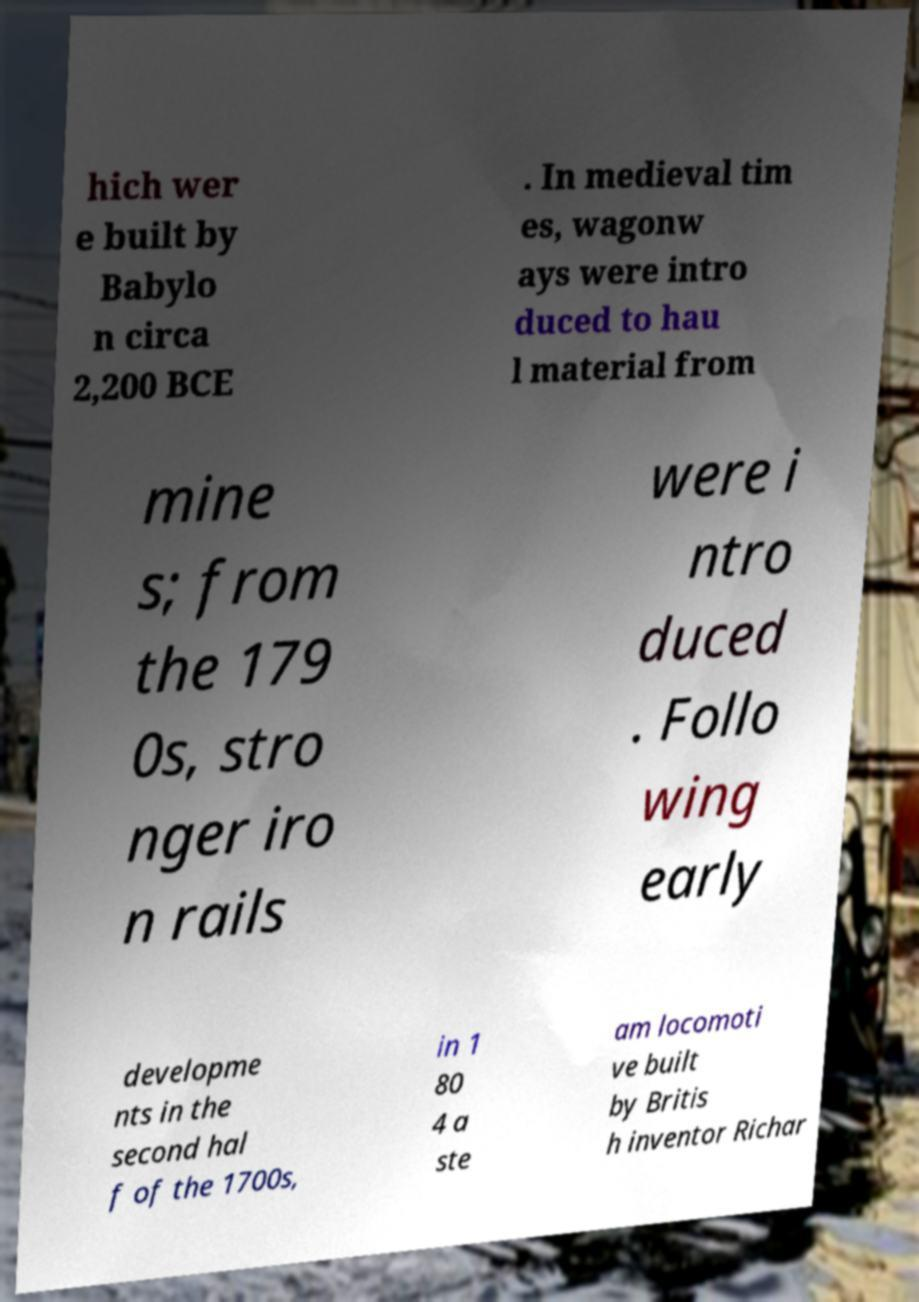Please identify and transcribe the text found in this image. hich wer e built by Babylo n circa 2,200 BCE . In medieval tim es, wagonw ays were intro duced to hau l material from mine s; from the 179 0s, stro nger iro n rails were i ntro duced . Follo wing early developme nts in the second hal f of the 1700s, in 1 80 4 a ste am locomoti ve built by Britis h inventor Richar 